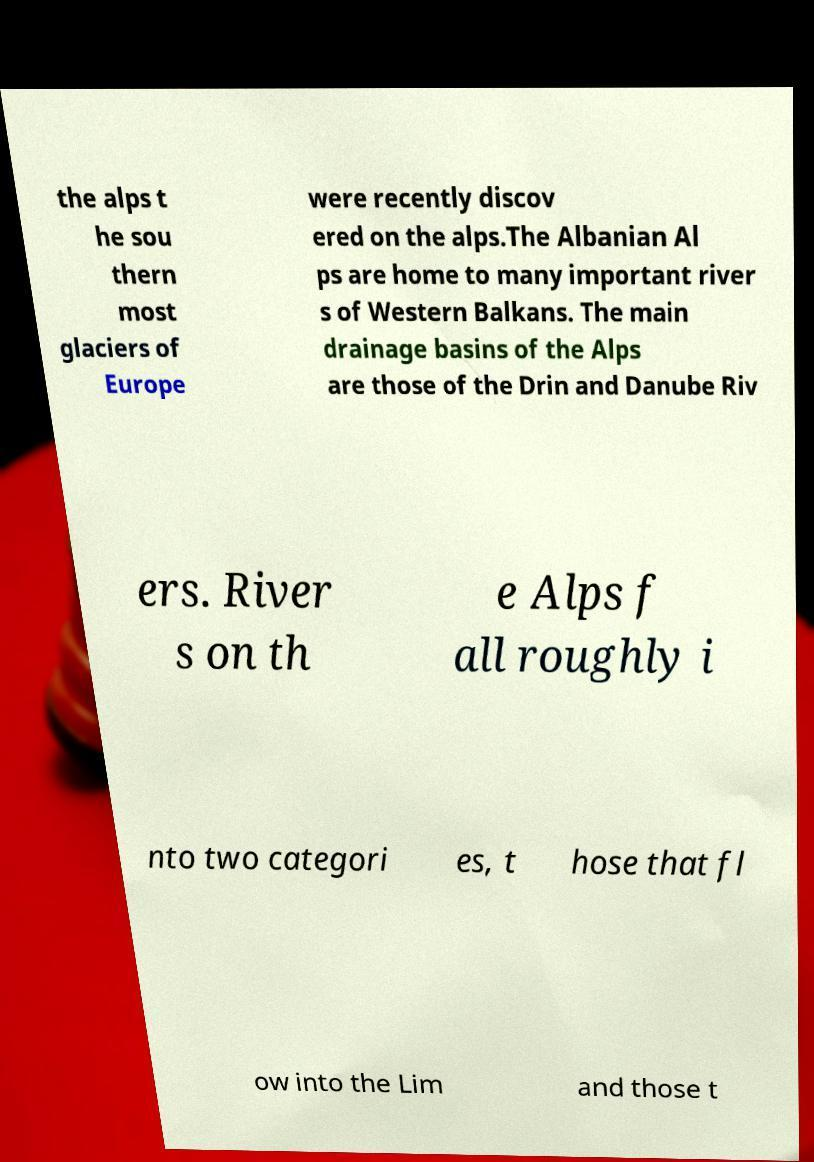Please identify and transcribe the text found in this image. the alps t he sou thern most glaciers of Europe were recently discov ered on the alps.The Albanian Al ps are home to many important river s of Western Balkans. The main drainage basins of the Alps are those of the Drin and Danube Riv ers. River s on th e Alps f all roughly i nto two categori es, t hose that fl ow into the Lim and those t 